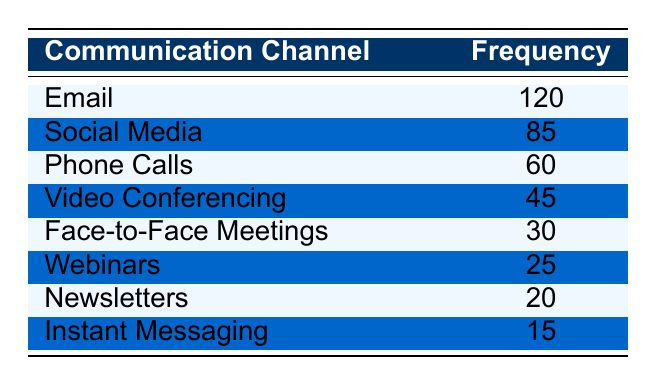What's the frequency of the Email communication channel? The table clearly lists the frequency for each channel. For Email, it shows a frequency of 120.
Answer: 120 What is the communication channel with the second highest frequency? By reviewing the frequencies, Social Media ranks second with a frequency of 85, following Email, which has the highest frequency at 120.
Answer: Social Media How many more frequencies does Phone Calls have compared to Face-to-Face Meetings? The frequency for Phone Calls is 60, and for Face-to-Face Meetings, it is 30. The difference is calculated as 60 - 30 = 30.
Answer: 30 What is the total frequency of all communication channels listed? We sum all the frequencies: 120 + 85 + 60 + 45 + 30 + 25 + 20 + 15 = 400. The total frequency adds up to 400.
Answer: 400 Is the frequency of Webinars greater than Instant Messaging? The frequency for Webinars is 25 while for Instant Messaging it is 15. Since 25 is greater than 15, the statement is true.
Answer: Yes Which communication channel has the least frequency, and what is that frequency? The channel with the least frequency is Instant Messaging, which has a frequency of 15, making it the lowest compared to the others.
Answer: Instant Messaging, 15 What is the average frequency of the communication channels used? To find the average, first calculate the total frequency (400) as previously done, then divide by the number of channels (8): 400 / 8 = 50. Therefore, the average is 50.
Answer: 50 Is the frequency of Video Conferencing higher than both Newsletters and Instant Messaging combined? The frequency for Video Conferencing is 45. The combined frequencies of Newsletters (20) and Instant Messaging (15) are 20 + 15 = 35. Since 45 is greater than 35, the statement is true.
Answer: Yes What is the total frequency of the top three communication channels? The top three channels are Email (120), Social Media (85), and Phone Calls (60). Adding these gives: 120 + 85 + 60 = 265. Thus, the total is 265.
Answer: 265 